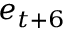<formula> <loc_0><loc_0><loc_500><loc_500>e _ { t + 6 }</formula> 